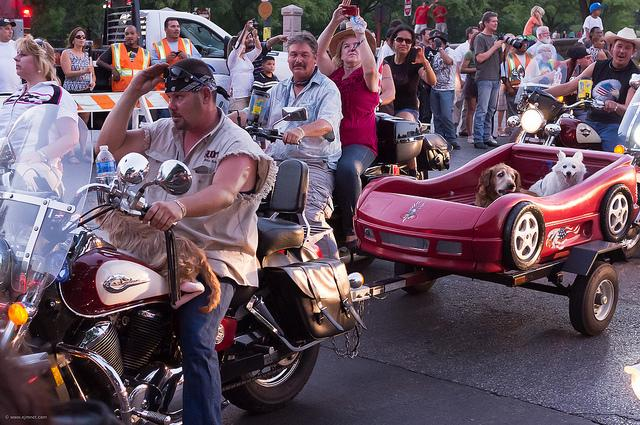The dogs face danger of falling off if the rider does what?

Choices:
A) stops
B) speeds
C) yells
D) sings speeds 